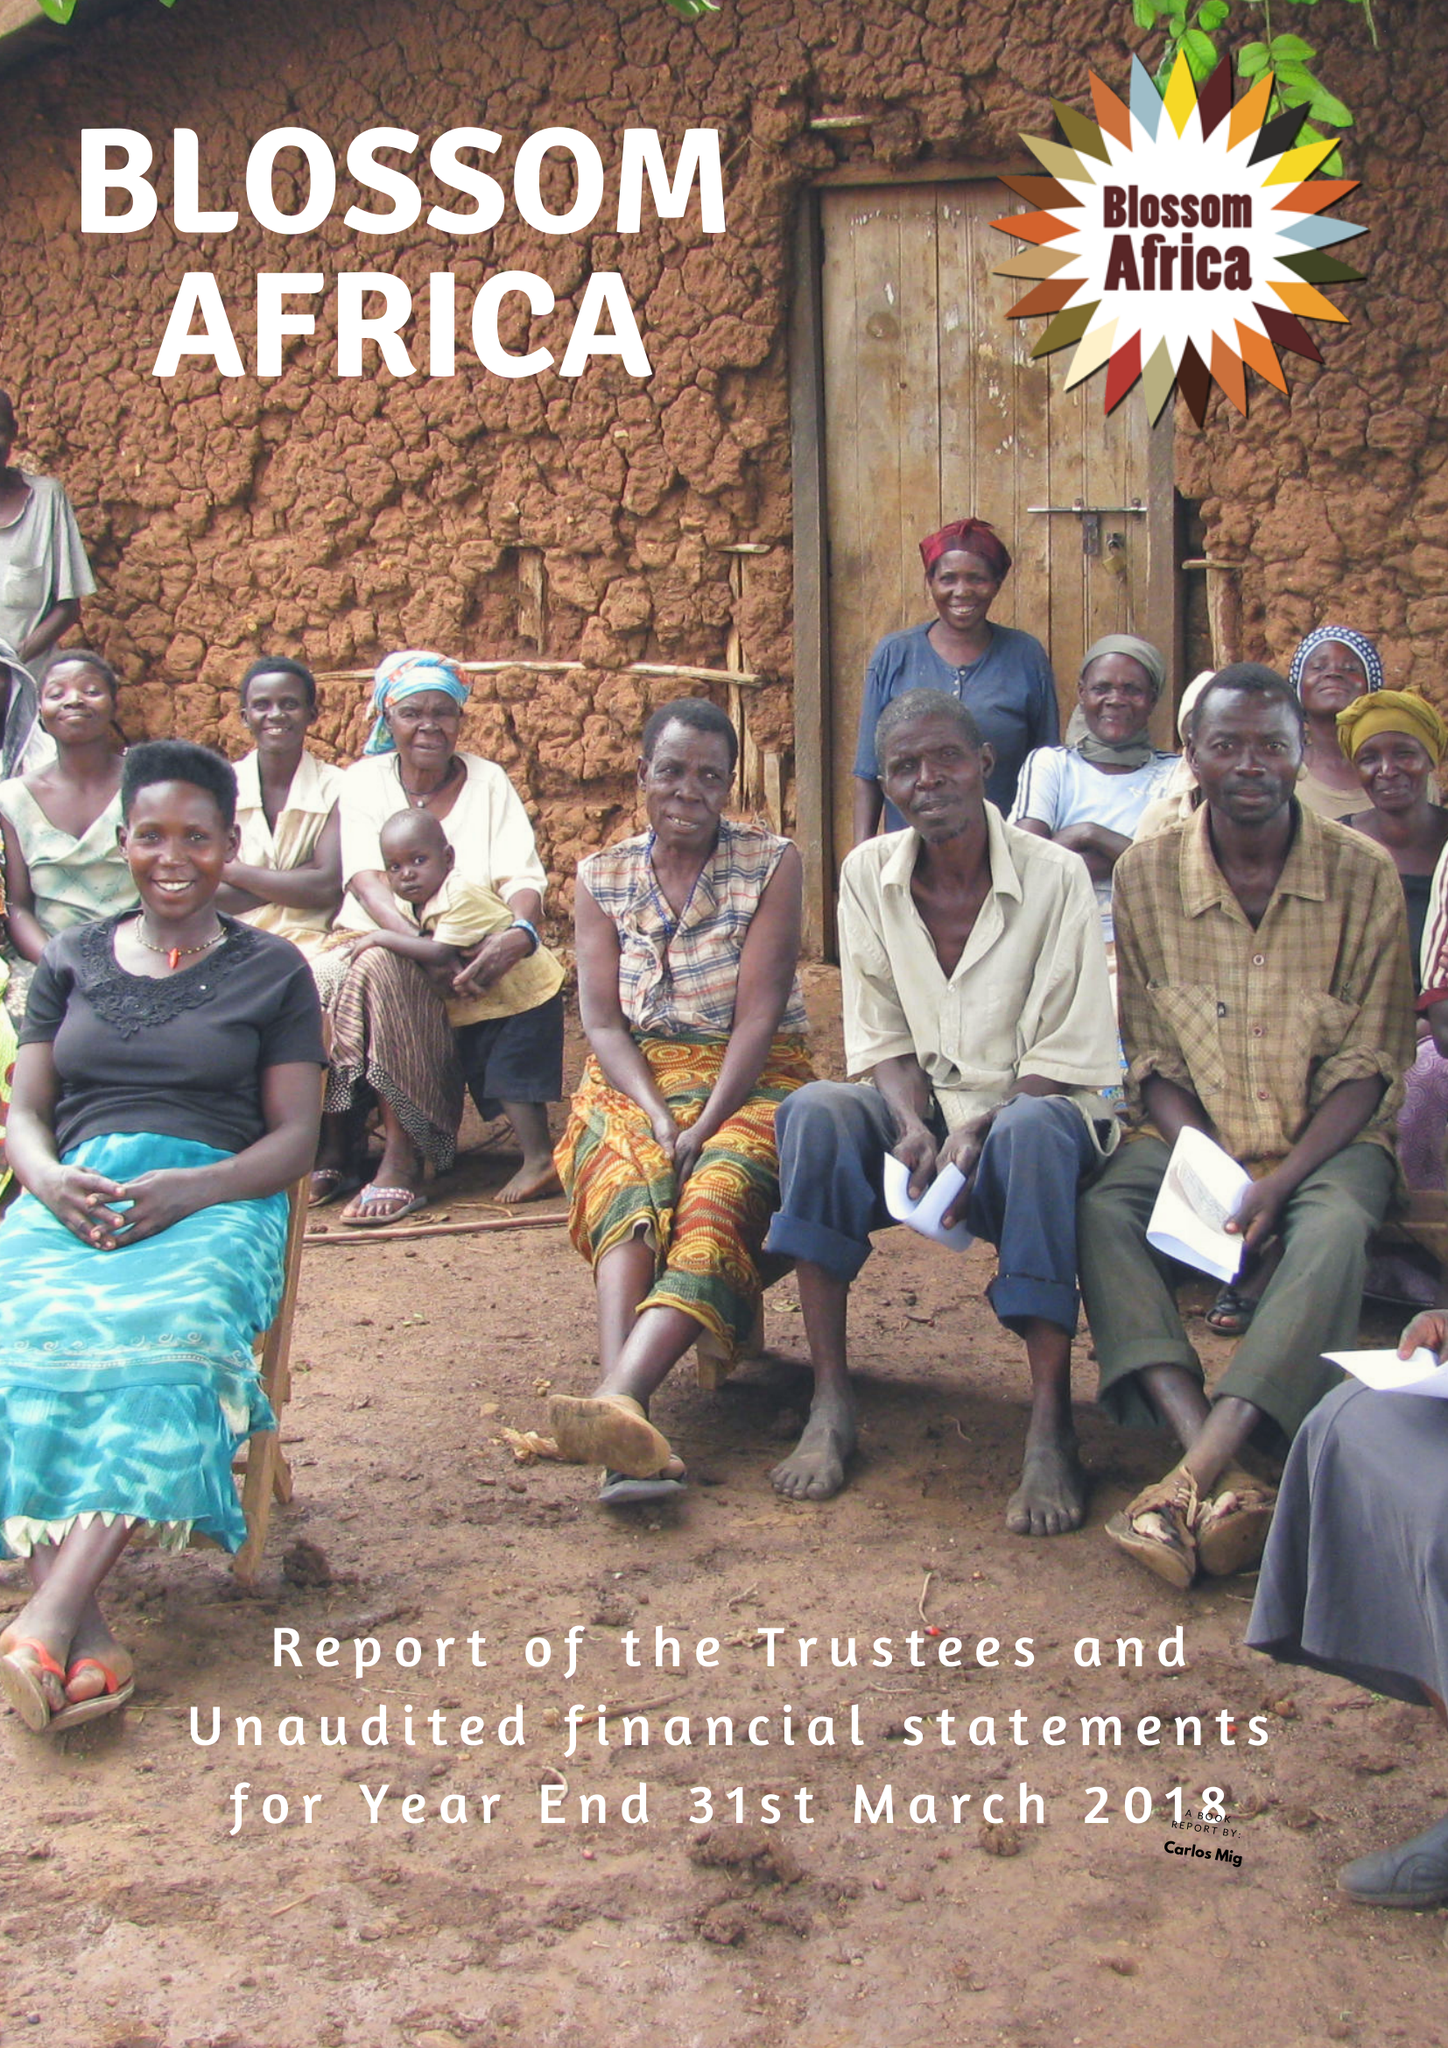What is the value for the report_date?
Answer the question using a single word or phrase. 2018-04-01 